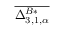<formula> <loc_0><loc_0><loc_500><loc_500>\overline { { \Delta _ { 3 , 1 , \alpha } ^ { B * } } }</formula> 